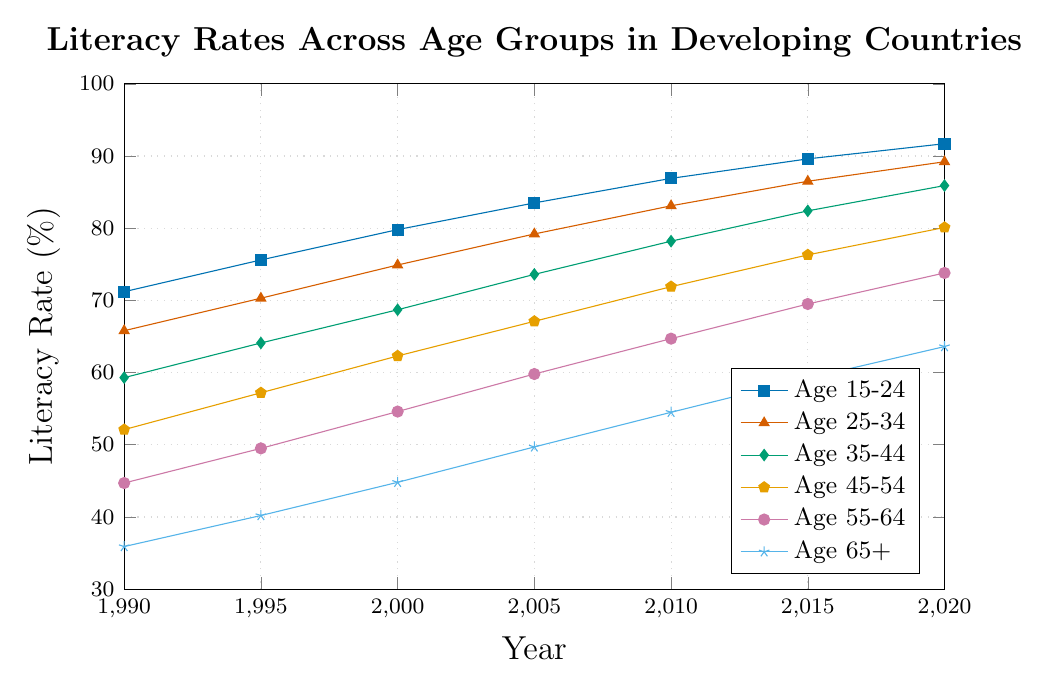what has been the average literacy rate for the Age 35-44 group from 1990 to 2020? The literacy rates for the Age 35-44 group over the years are: 59.3, 64.1, 68.7, 73.6, 78.2, 82.4, and 85.9. Summing these values gives 59.3 + 64.1 + 68.7 + 73.6 + 78.2 + 82.4 + 85.9 = 512.2. Dividing by 7 (the number of data points), we have 512.2 / 7 ≈ 73.17
Answer: 73.17 Which age group showed the highest increase in literacy rate between 1990 and 2020? To find the highest increase, calculate the difference for each age group between 1990 and 2020: Age 15-24: 91.7 - 71.2 = 20.5, Age 25-34: 89.2 - 65.8 = 23.4, Age 35-44: 85.9 - 59.3 = 26.6, Age 45-54: 80.1 - 52.1 = 28.0, Age 55-64: 73.8 - 44.7 = 29.1, Age 65+: 63.6 - 35.9 = 27.7. The highest increase is for the Age 55-64 group with 29.1
Answer: Age 55-64 In what year did all age groups reach at least 50% literacy rate? Checking each year: In 1990, Age 45-54, Age 55-64, and Age 65+ are below 50%; In 1995, Age 55-64 and Age 65+ are still below 50%; In 2000, only Age 65+ is below 50%; In 2005, the Age 65+ group has reached 49.7%. So in 2010, all values are above 50: 54.5 (Age 65+) is the lowest which is above 50%
Answer: 2010 Which age group had the smallest increase in literacy rates from 1990 to 2010? Calculate the difference for each age group between 1990 and 2010: Age 15-24: 86.9 - 71.2 = 15.7, Age 25-34: 83.1 - 65.8 = 17.3, Age 35-44: 78.2 - 59.3 = 18.9, Age 45-54: 71.9 - 52.1 = 19.8, Age 55-64: 64.7 - 44.7 = 20, Age 65+: 54.5 - 35.9 = 18.6. The smallest increase is for the Age 15-24 group with 15.7
Answer: Age 15-24 What is the average literacy rate for all age groups in the year 2005? The literacy rates for 2005 are: 83.5, 79.2, 73.6, 67.1, 59.8, 49.7. Summing these gives 83.5 + 79.2 + 73.6 + 67.1 + 59.8 + 49.7 = 412.9. Dividing by 6 (the number of age groups), we get 412.9 / 6 ≈ 68.82
Answer: 68.82 Between 1990 and 2020, did any age group see an increase of over 30 percentage points? Checking the differences: Age 15-24: 91.7 - 71.2 = 20.5, Age 25-34: 89.2 - 65.8 = 23.4, Age 35-44: 85.9 - 59.3 = 26.6, Age 45-54: 80.1 - 52.1 = 28.0, Age 55-64: 73.8 - 44.7 = 29.1, Age 65+: 63.6 - 35.9 = 27.7. No age group had an increase of over 30 percentage points
Answer: No By how much did the literacy rate of the Age 45-54 group increase between 1995 and 2015? The literacy rate for the Age 45-54 group in 1995 was 57.2 and in 2015 it was 76.3. The increase is 76.3 - 57.2 = 19.1
Answer: 19.1 Which age group consistently had the lowest literacy rate throughout the period 1990-2020? The values for Age 65+ are 35.9, 40.2, 44.8, 49.7, 54.5, 59.2, and 63.6, which are the lowest compared to corresponding values for other groups in each of these years
Answer: Age 65+ 